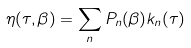Convert formula to latex. <formula><loc_0><loc_0><loc_500><loc_500>\eta ( \tau , \beta ) = \sum _ { n } P _ { n } ( \beta ) k _ { n } ( \tau )</formula> 